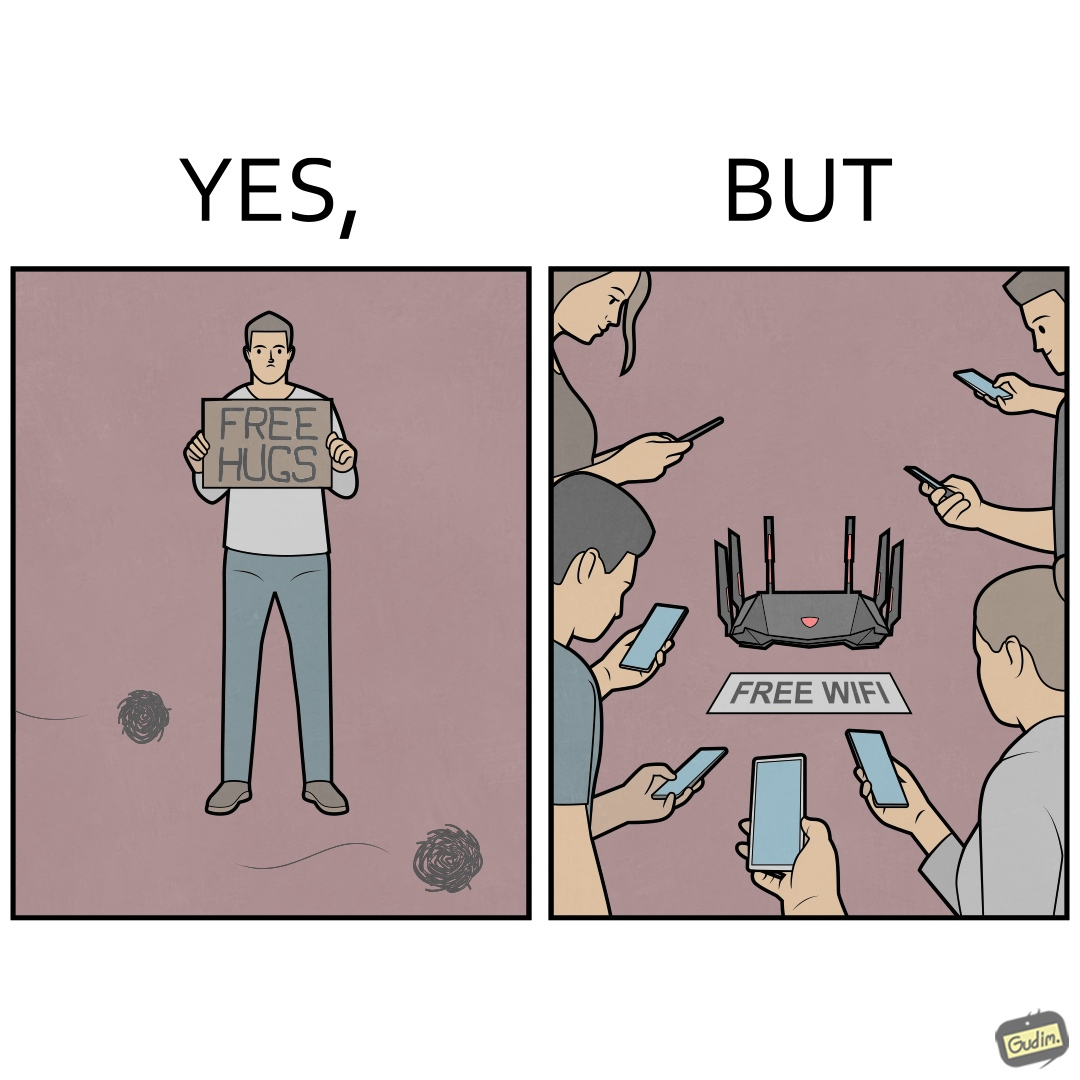Explain the humor or irony in this image. This image is ironical, as a person holding up a "Free Hugs" sign is standing alone, while an inanimate Wi-fi Router giving "Free Wifi" is surrounded people trying to connect to it. This shows a growing lack of empathy in our society, while showing our increasing dependence on the digital devices in a virtual world. 